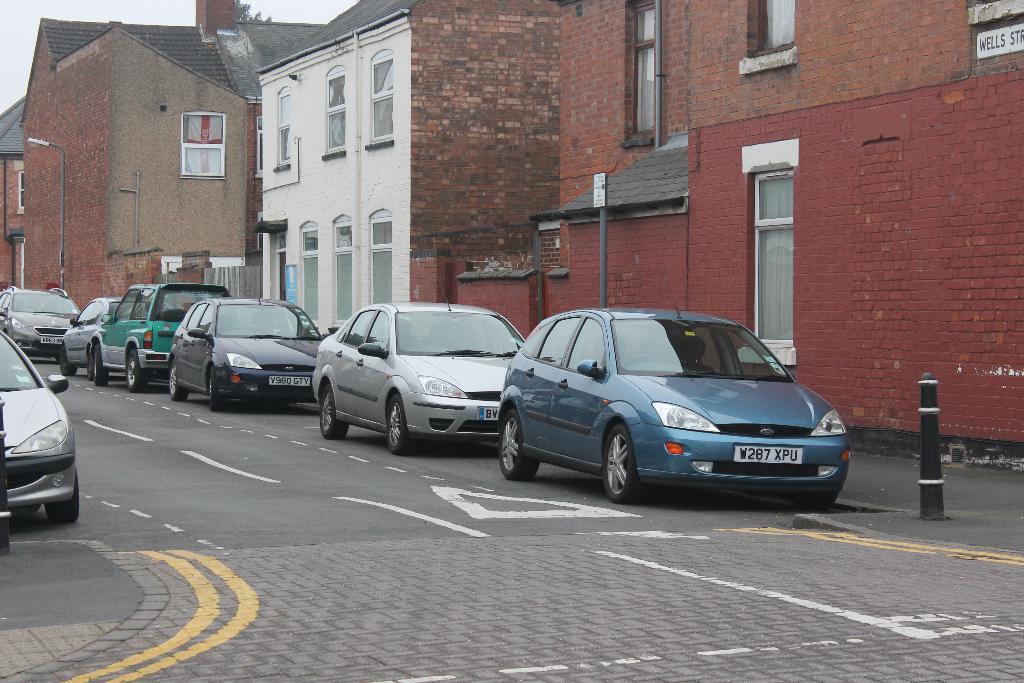Describe this image in one or two sentences. This picture consists of building , in front of building there are vehicles parking on road and some poles visible in front of building , in the top left there is the sky visible. 